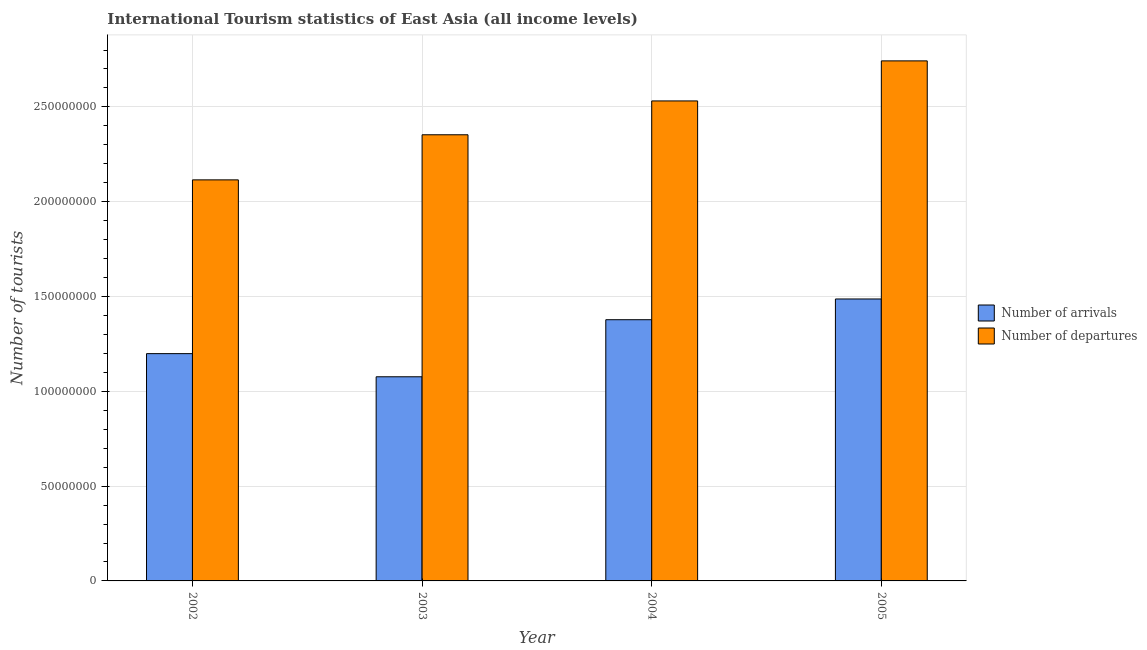How many different coloured bars are there?
Offer a terse response. 2. Are the number of bars per tick equal to the number of legend labels?
Give a very brief answer. Yes. How many bars are there on the 4th tick from the left?
Ensure brevity in your answer.  2. How many bars are there on the 3rd tick from the right?
Offer a very short reply. 2. What is the label of the 1st group of bars from the left?
Offer a terse response. 2002. What is the number of tourist arrivals in 2003?
Give a very brief answer. 1.08e+08. Across all years, what is the maximum number of tourist arrivals?
Your answer should be compact. 1.49e+08. Across all years, what is the minimum number of tourist departures?
Offer a very short reply. 2.12e+08. In which year was the number of tourist departures maximum?
Offer a very short reply. 2005. In which year was the number of tourist arrivals minimum?
Keep it short and to the point. 2003. What is the total number of tourist arrivals in the graph?
Provide a short and direct response. 5.14e+08. What is the difference between the number of tourist departures in 2003 and that in 2005?
Offer a terse response. -3.90e+07. What is the difference between the number of tourist departures in 2003 and the number of tourist arrivals in 2005?
Your answer should be very brief. -3.90e+07. What is the average number of tourist departures per year?
Your answer should be very brief. 2.44e+08. In the year 2003, what is the difference between the number of tourist departures and number of tourist arrivals?
Give a very brief answer. 0. In how many years, is the number of tourist departures greater than 10000000?
Offer a terse response. 4. What is the ratio of the number of tourist arrivals in 2004 to that in 2005?
Your response must be concise. 0.93. Is the number of tourist arrivals in 2002 less than that in 2003?
Your answer should be very brief. No. What is the difference between the highest and the second highest number of tourist arrivals?
Your answer should be very brief. 1.09e+07. What is the difference between the highest and the lowest number of tourist departures?
Offer a very short reply. 6.28e+07. In how many years, is the number of tourist arrivals greater than the average number of tourist arrivals taken over all years?
Give a very brief answer. 2. Is the sum of the number of tourist arrivals in 2004 and 2005 greater than the maximum number of tourist departures across all years?
Ensure brevity in your answer.  Yes. What does the 1st bar from the left in 2003 represents?
Offer a terse response. Number of arrivals. What does the 1st bar from the right in 2004 represents?
Ensure brevity in your answer.  Number of departures. How many years are there in the graph?
Give a very brief answer. 4. Are the values on the major ticks of Y-axis written in scientific E-notation?
Give a very brief answer. No. Does the graph contain grids?
Make the answer very short. Yes. Where does the legend appear in the graph?
Your answer should be compact. Center right. How many legend labels are there?
Your response must be concise. 2. How are the legend labels stacked?
Give a very brief answer. Vertical. What is the title of the graph?
Offer a very short reply. International Tourism statistics of East Asia (all income levels). What is the label or title of the X-axis?
Your response must be concise. Year. What is the label or title of the Y-axis?
Provide a succinct answer. Number of tourists. What is the Number of tourists of Number of arrivals in 2002?
Provide a short and direct response. 1.20e+08. What is the Number of tourists in Number of departures in 2002?
Offer a terse response. 2.12e+08. What is the Number of tourists of Number of arrivals in 2003?
Offer a very short reply. 1.08e+08. What is the Number of tourists in Number of departures in 2003?
Offer a terse response. 2.35e+08. What is the Number of tourists in Number of arrivals in 2004?
Your answer should be compact. 1.38e+08. What is the Number of tourists in Number of departures in 2004?
Your answer should be compact. 2.53e+08. What is the Number of tourists of Number of arrivals in 2005?
Your answer should be compact. 1.49e+08. What is the Number of tourists in Number of departures in 2005?
Offer a terse response. 2.74e+08. Across all years, what is the maximum Number of tourists in Number of arrivals?
Your answer should be compact. 1.49e+08. Across all years, what is the maximum Number of tourists in Number of departures?
Your response must be concise. 2.74e+08. Across all years, what is the minimum Number of tourists of Number of arrivals?
Your response must be concise. 1.08e+08. Across all years, what is the minimum Number of tourists of Number of departures?
Give a very brief answer. 2.12e+08. What is the total Number of tourists in Number of arrivals in the graph?
Your response must be concise. 5.14e+08. What is the total Number of tourists of Number of departures in the graph?
Offer a terse response. 9.74e+08. What is the difference between the Number of tourists of Number of arrivals in 2002 and that in 2003?
Provide a short and direct response. 1.22e+07. What is the difference between the Number of tourists in Number of departures in 2002 and that in 2003?
Provide a succinct answer. -2.38e+07. What is the difference between the Number of tourists of Number of arrivals in 2002 and that in 2004?
Give a very brief answer. -1.79e+07. What is the difference between the Number of tourists in Number of departures in 2002 and that in 2004?
Give a very brief answer. -4.16e+07. What is the difference between the Number of tourists in Number of arrivals in 2002 and that in 2005?
Your answer should be very brief. -2.88e+07. What is the difference between the Number of tourists of Number of departures in 2002 and that in 2005?
Make the answer very short. -6.28e+07. What is the difference between the Number of tourists in Number of arrivals in 2003 and that in 2004?
Offer a terse response. -3.01e+07. What is the difference between the Number of tourists in Number of departures in 2003 and that in 2004?
Your response must be concise. -1.79e+07. What is the difference between the Number of tourists of Number of arrivals in 2003 and that in 2005?
Your answer should be compact. -4.10e+07. What is the difference between the Number of tourists in Number of departures in 2003 and that in 2005?
Your answer should be very brief. -3.90e+07. What is the difference between the Number of tourists of Number of arrivals in 2004 and that in 2005?
Keep it short and to the point. -1.09e+07. What is the difference between the Number of tourists in Number of departures in 2004 and that in 2005?
Ensure brevity in your answer.  -2.11e+07. What is the difference between the Number of tourists of Number of arrivals in 2002 and the Number of tourists of Number of departures in 2003?
Make the answer very short. -1.15e+08. What is the difference between the Number of tourists of Number of arrivals in 2002 and the Number of tourists of Number of departures in 2004?
Your answer should be very brief. -1.33e+08. What is the difference between the Number of tourists of Number of arrivals in 2002 and the Number of tourists of Number of departures in 2005?
Provide a succinct answer. -1.54e+08. What is the difference between the Number of tourists of Number of arrivals in 2003 and the Number of tourists of Number of departures in 2004?
Offer a very short reply. -1.45e+08. What is the difference between the Number of tourists in Number of arrivals in 2003 and the Number of tourists in Number of departures in 2005?
Provide a short and direct response. -1.67e+08. What is the difference between the Number of tourists in Number of arrivals in 2004 and the Number of tourists in Number of departures in 2005?
Offer a terse response. -1.37e+08. What is the average Number of tourists of Number of arrivals per year?
Provide a succinct answer. 1.29e+08. What is the average Number of tourists in Number of departures per year?
Offer a very short reply. 2.44e+08. In the year 2002, what is the difference between the Number of tourists in Number of arrivals and Number of tourists in Number of departures?
Offer a very short reply. -9.16e+07. In the year 2003, what is the difference between the Number of tourists of Number of arrivals and Number of tourists of Number of departures?
Offer a terse response. -1.28e+08. In the year 2004, what is the difference between the Number of tourists of Number of arrivals and Number of tourists of Number of departures?
Provide a short and direct response. -1.15e+08. In the year 2005, what is the difference between the Number of tourists of Number of arrivals and Number of tourists of Number of departures?
Give a very brief answer. -1.26e+08. What is the ratio of the Number of tourists in Number of arrivals in 2002 to that in 2003?
Offer a very short reply. 1.11. What is the ratio of the Number of tourists in Number of departures in 2002 to that in 2003?
Keep it short and to the point. 0.9. What is the ratio of the Number of tourists of Number of arrivals in 2002 to that in 2004?
Provide a succinct answer. 0.87. What is the ratio of the Number of tourists in Number of departures in 2002 to that in 2004?
Ensure brevity in your answer.  0.84. What is the ratio of the Number of tourists in Number of arrivals in 2002 to that in 2005?
Provide a short and direct response. 0.81. What is the ratio of the Number of tourists of Number of departures in 2002 to that in 2005?
Provide a short and direct response. 0.77. What is the ratio of the Number of tourists of Number of arrivals in 2003 to that in 2004?
Offer a very short reply. 0.78. What is the ratio of the Number of tourists in Number of departures in 2003 to that in 2004?
Provide a succinct answer. 0.93. What is the ratio of the Number of tourists of Number of arrivals in 2003 to that in 2005?
Your response must be concise. 0.72. What is the ratio of the Number of tourists of Number of departures in 2003 to that in 2005?
Provide a short and direct response. 0.86. What is the ratio of the Number of tourists in Number of arrivals in 2004 to that in 2005?
Keep it short and to the point. 0.93. What is the ratio of the Number of tourists in Number of departures in 2004 to that in 2005?
Your answer should be compact. 0.92. What is the difference between the highest and the second highest Number of tourists of Number of arrivals?
Provide a short and direct response. 1.09e+07. What is the difference between the highest and the second highest Number of tourists in Number of departures?
Make the answer very short. 2.11e+07. What is the difference between the highest and the lowest Number of tourists in Number of arrivals?
Make the answer very short. 4.10e+07. What is the difference between the highest and the lowest Number of tourists of Number of departures?
Ensure brevity in your answer.  6.28e+07. 